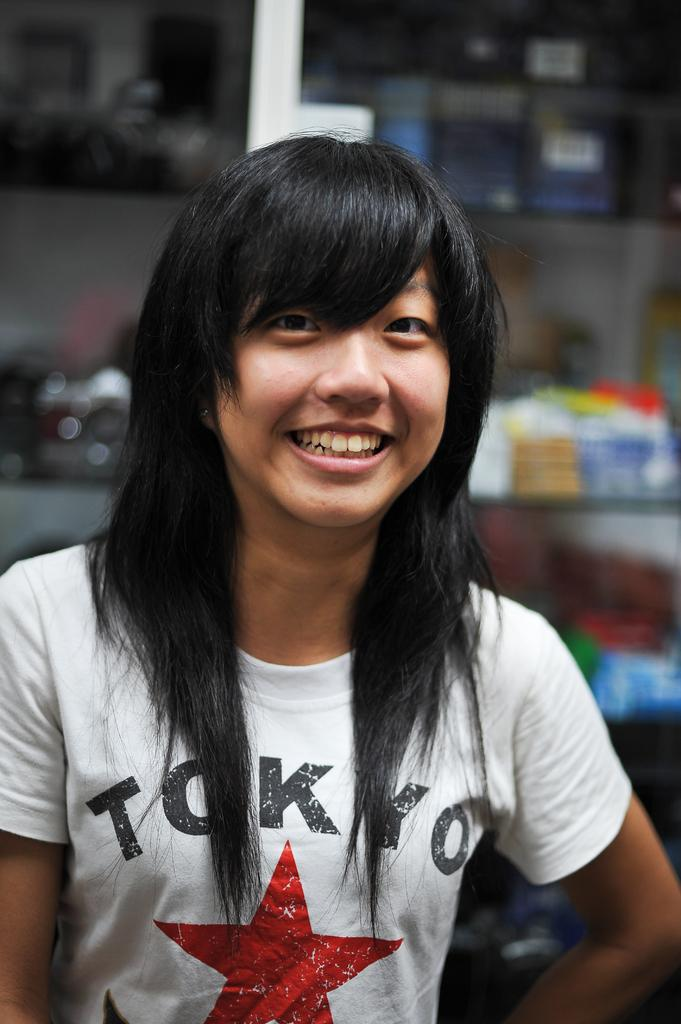Who is the main subject in the image? There is a woman in the image. What is the woman wearing? The woman is wearing a white t-shirt. What can be seen in the background of the image? There are shelves in the background of the image. How would you describe the background of the image? The background of the image is slightly blurred. What type of guide is the woman holding in the image? There is no guide present in the image; the woman is simply standing and wearing a white t-shirt. What kind of line is visible on the shelves in the image? There is no line visible on the shelves in the image; only the shelves themselves can be seen. 